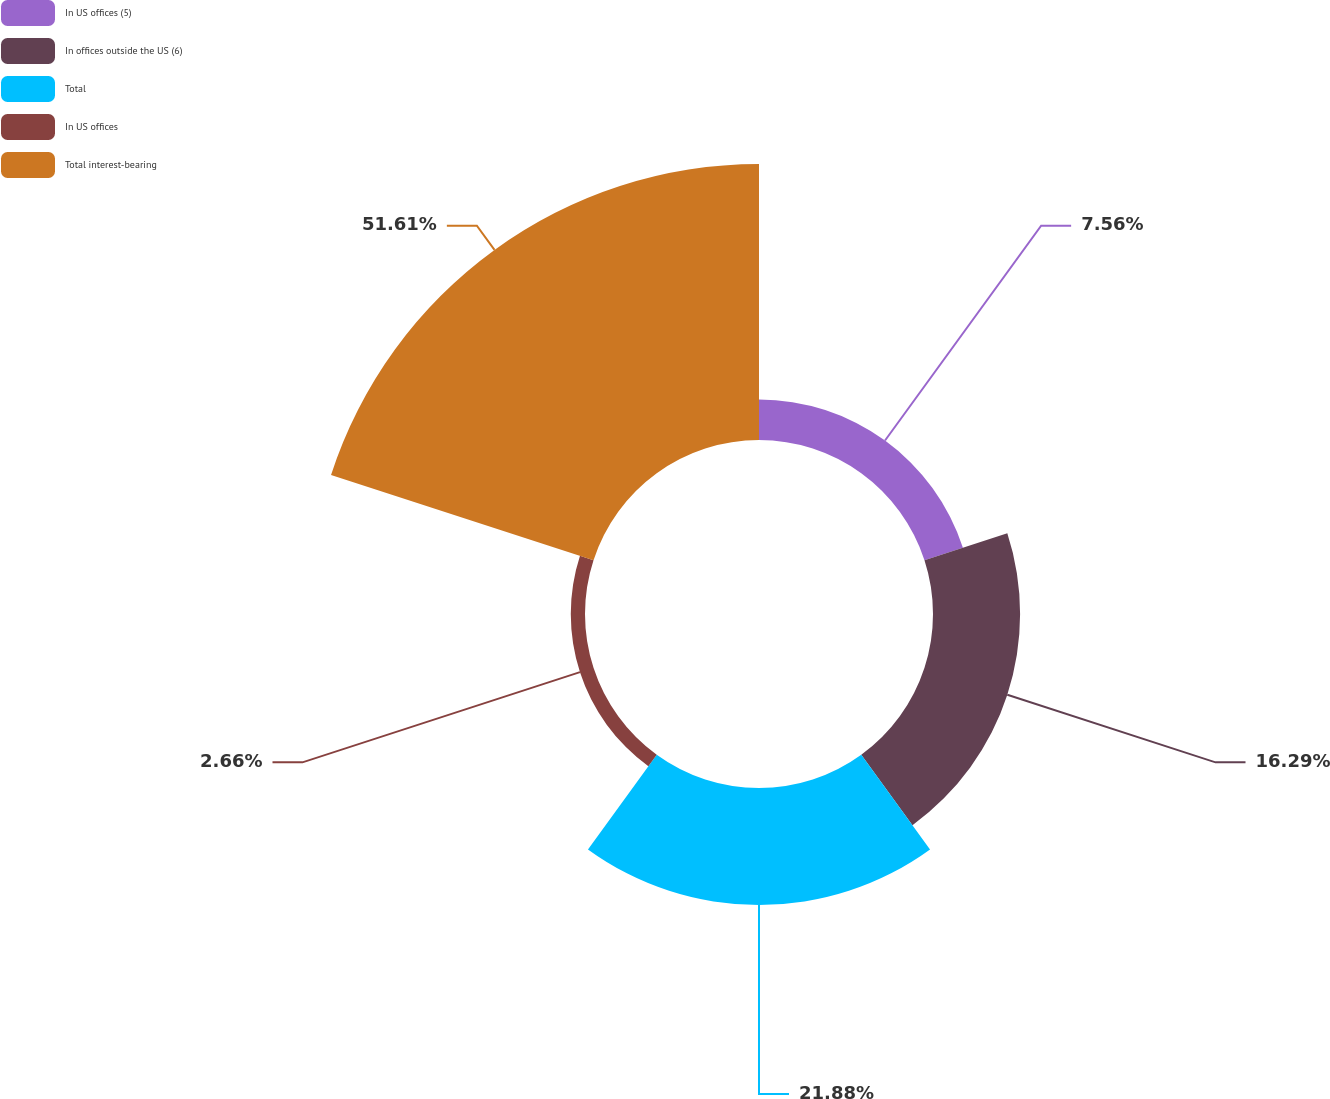<chart> <loc_0><loc_0><loc_500><loc_500><pie_chart><fcel>In US offices (5)<fcel>In offices outside the US (6)<fcel>Total<fcel>In US offices<fcel>Total interest-bearing<nl><fcel>7.56%<fcel>16.29%<fcel>21.88%<fcel>2.66%<fcel>51.62%<nl></chart> 